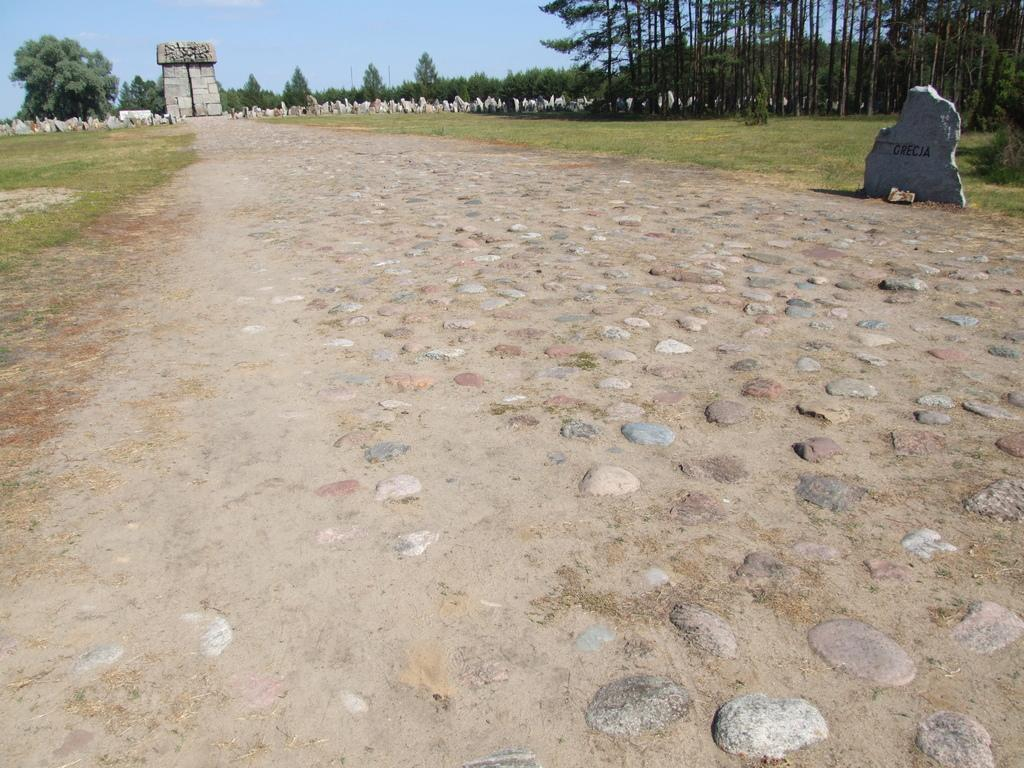What type of surface is visible in the image? There is a road in the image. How is the road constructed? The road is filled with stones. What type of vegetation is near the road? There is grass near the road. What other structures can be seen in the image? There is a stone wall in the image. What is located behind the stone wall? Trees are present behind the stone wall. How much wealth does the father in the image possess? There is no father present in the image, so it is not possible to determine his wealth. 